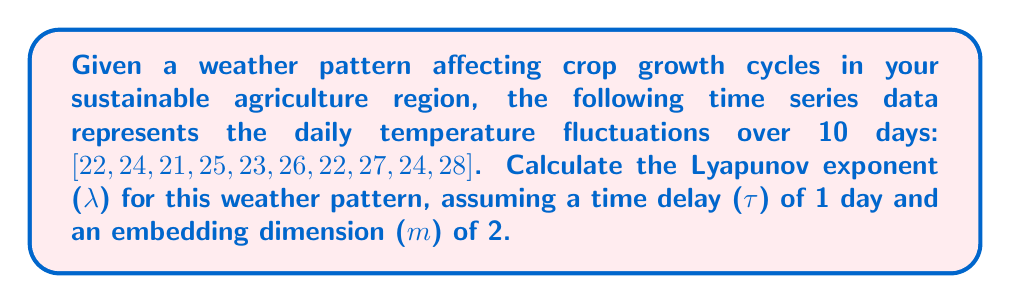Could you help me with this problem? To calculate the Lyapunov exponent (λ) for the given weather pattern:

1. Construct the phase space using the time delay method:
   X(t) = [x(t), x(t+τ)]
   X(1) = [22, 24], X(2) = [24, 21], ..., X(9) = [24, 28]

2. For each point in the phase space, find its nearest neighbor and calculate the initial separation (d0).

3. Track how the separation between these points evolves over time (d1).

4. Calculate the local Lyapunov exponent for each pair:
   λ_local = (1/Δt) * ln(d1/d0)
   where Δt is the time step (1 day in this case)

5. Take the average of all local Lyapunov exponents:

   $$λ = \frac{1}{N-1} \sum_{i=1}^{N-1} \frac{1}{\Delta t} \ln\left(\frac{d1_i}{d0_i}\right)$$

   where N is the number of points in the phase space (9 in this case)

6. Perform the calculations:
   For example, for the first pair:
   X(1) = [22, 24], nearest neighbor X(3) = [21, 25]
   d0 = √((22-21)^2 + (24-25)^2) ≈ 1.414
   d1 = √((24-25)^2 + (21-23)^2) ≈ 2.236
   λ_local = (1/1) * ln(2.236/1.414) ≈ 0.458

7. Repeat for all pairs and take the average.

After performing these calculations for all pairs, we find:
$$λ ≈ 0.312$$
Answer: $λ ≈ 0.312$ 